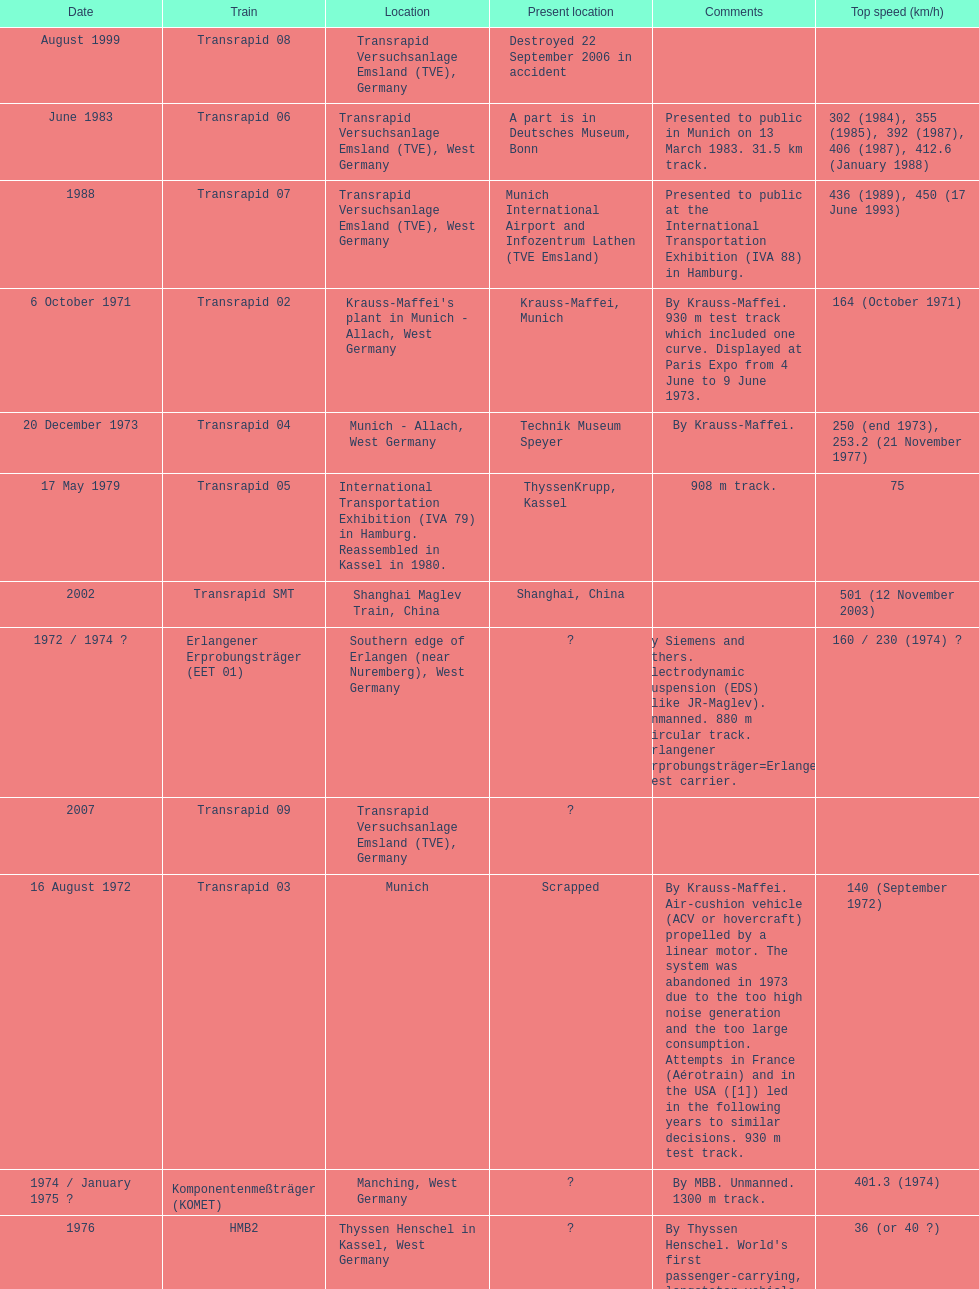How many trains other than the transrapid 07 can go faster than 450km/h? 1. 